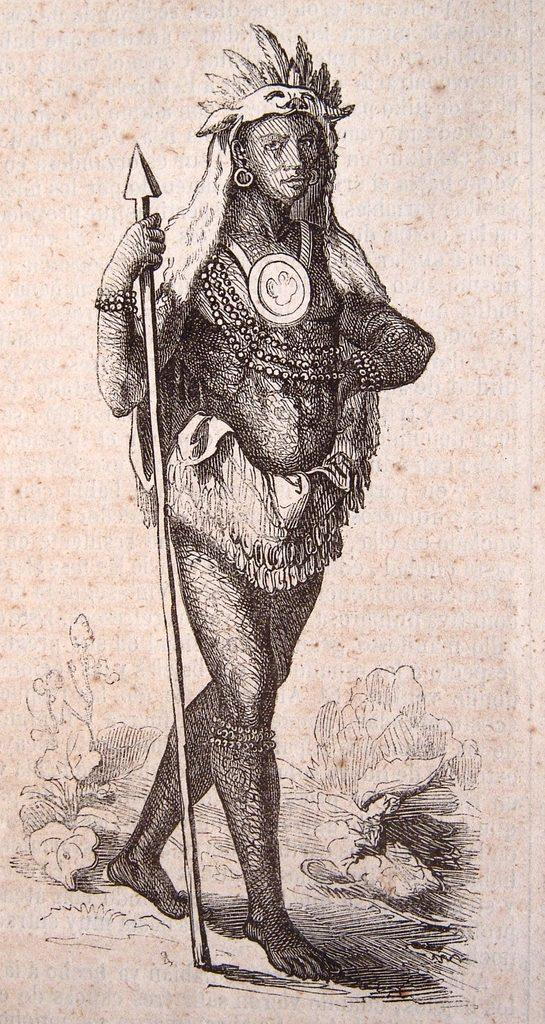What is depicted on the poster in the image? The poster contains a painting of a woman. What is the woman holding in the painting? The woman is holding an arrow in the painting. What other elements can be seen in the painting? There are flowers and a plant in the painting. What type of lipstick is the woman wearing in the painting? There is no lipstick mentioned or visible in the painting; the woman is holding an arrow. 